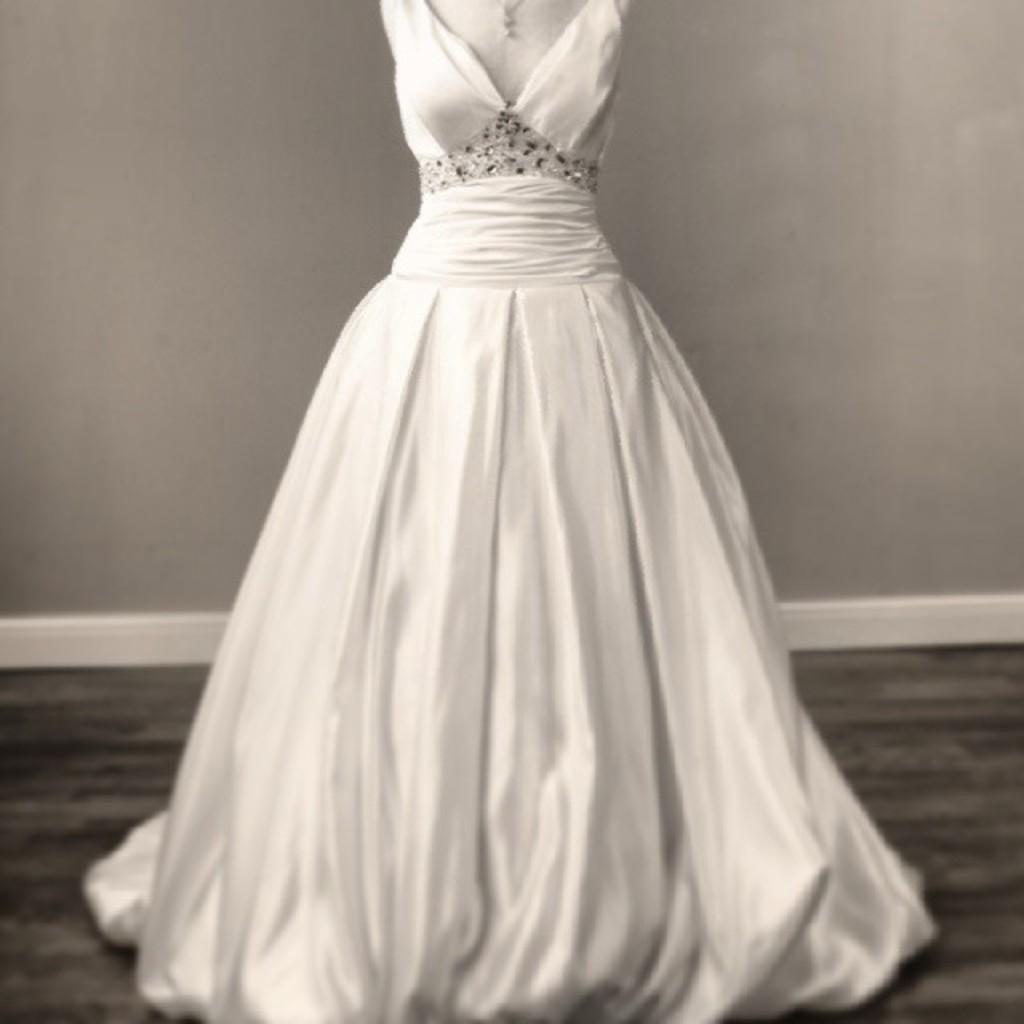How would you summarize this image in a sentence or two? In this picture there is a white long gown in the foreground, there is a wall in the background, and there is a floor at the bottom. 